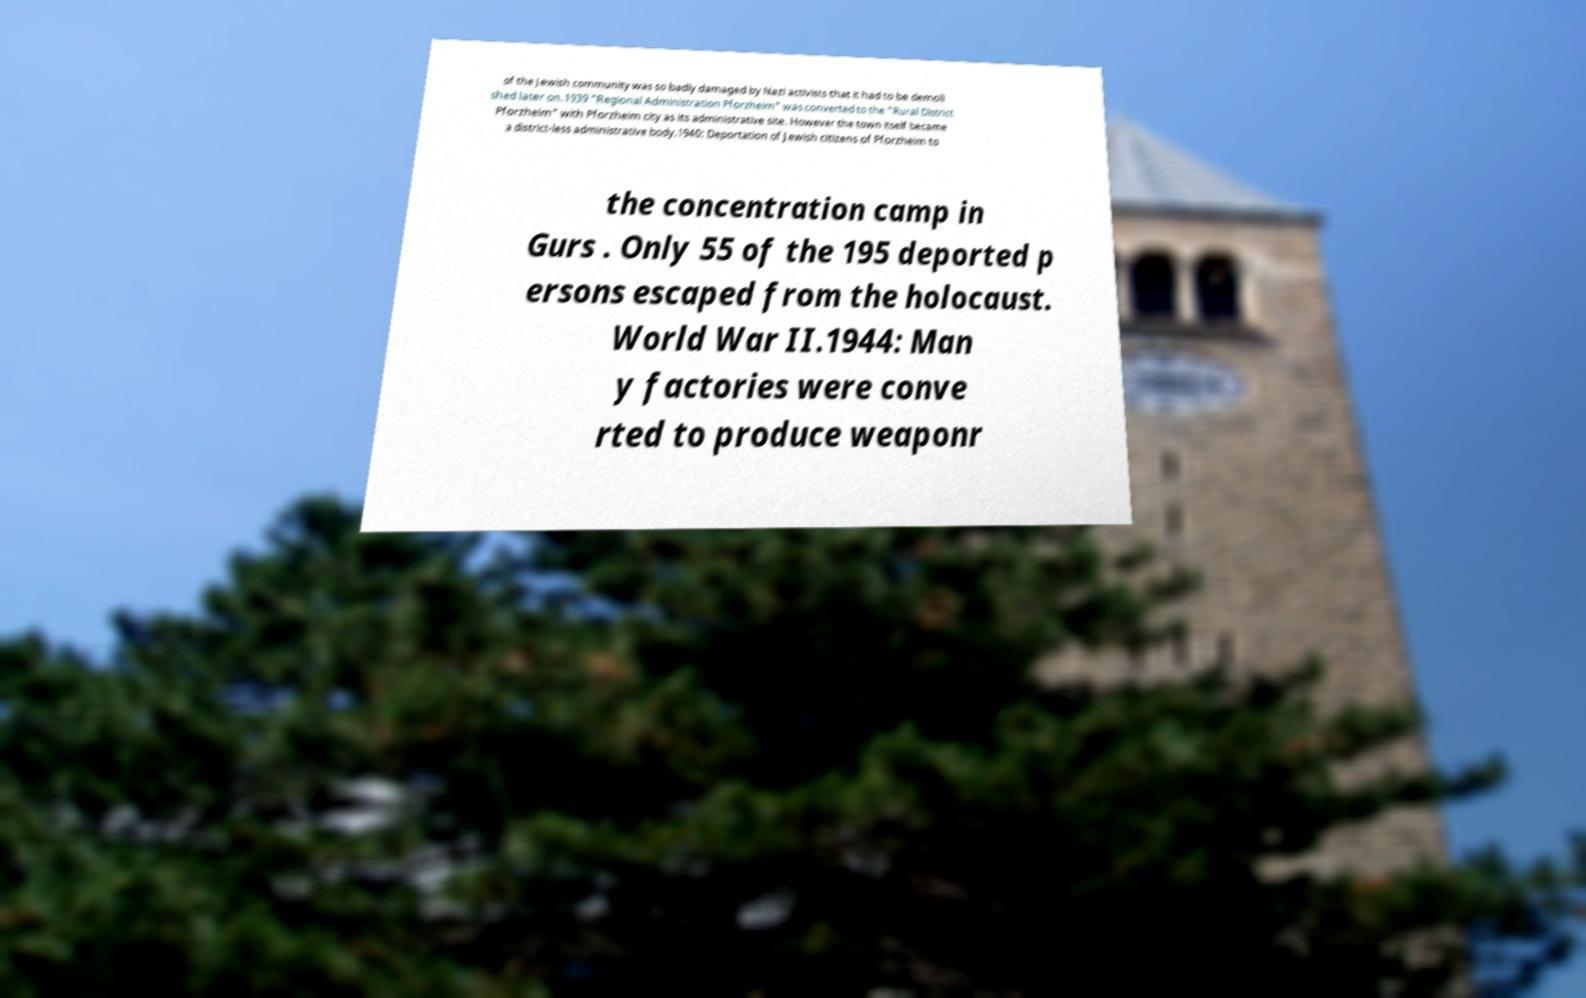Please read and relay the text visible in this image. What does it say? of the Jewish community was so badly damaged by Nazi activists that it had to be demoli shed later on.1939 "Regional Administration Pforzheim" was converted to the "Rural District Pforzheim" with Pforzheim city as its administrative site. However the town itself became a district-less administrative body.1940: Deportation of Jewish citizens of Pforzheim to the concentration camp in Gurs . Only 55 of the 195 deported p ersons escaped from the holocaust. World War II.1944: Man y factories were conve rted to produce weaponr 